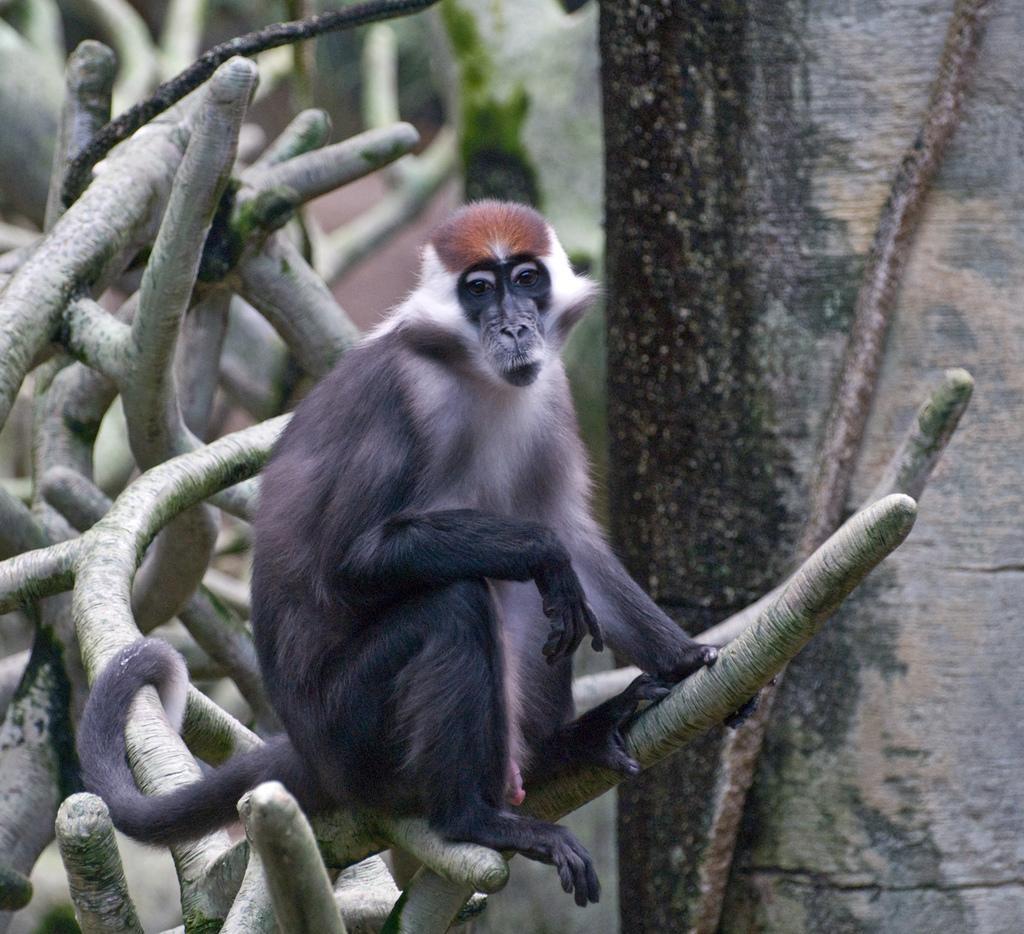In one or two sentences, can you explain what this image depicts? In this image we can see an animal on the tree. 